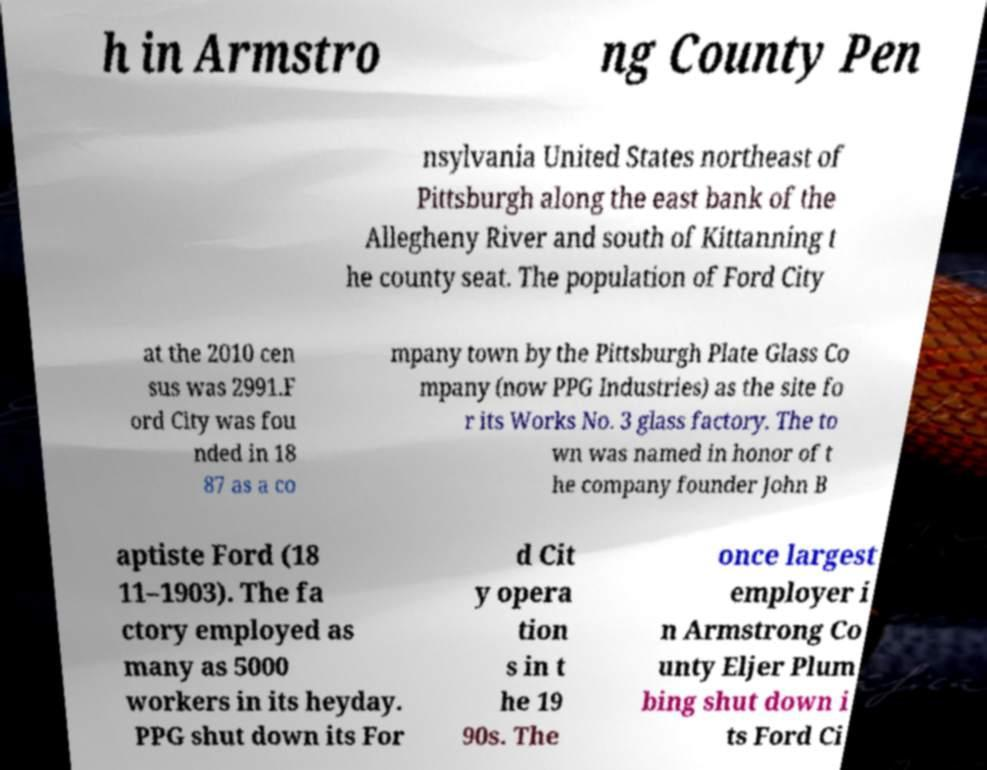What messages or text are displayed in this image? I need them in a readable, typed format. h in Armstro ng County Pen nsylvania United States northeast of Pittsburgh along the east bank of the Allegheny River and south of Kittanning t he county seat. The population of Ford City at the 2010 cen sus was 2991.F ord City was fou nded in 18 87 as a co mpany town by the Pittsburgh Plate Glass Co mpany (now PPG Industries) as the site fo r its Works No. 3 glass factory. The to wn was named in honor of t he company founder John B aptiste Ford (18 11–1903). The fa ctory employed as many as 5000 workers in its heyday. PPG shut down its For d Cit y opera tion s in t he 19 90s. The once largest employer i n Armstrong Co unty Eljer Plum bing shut down i ts Ford Ci 